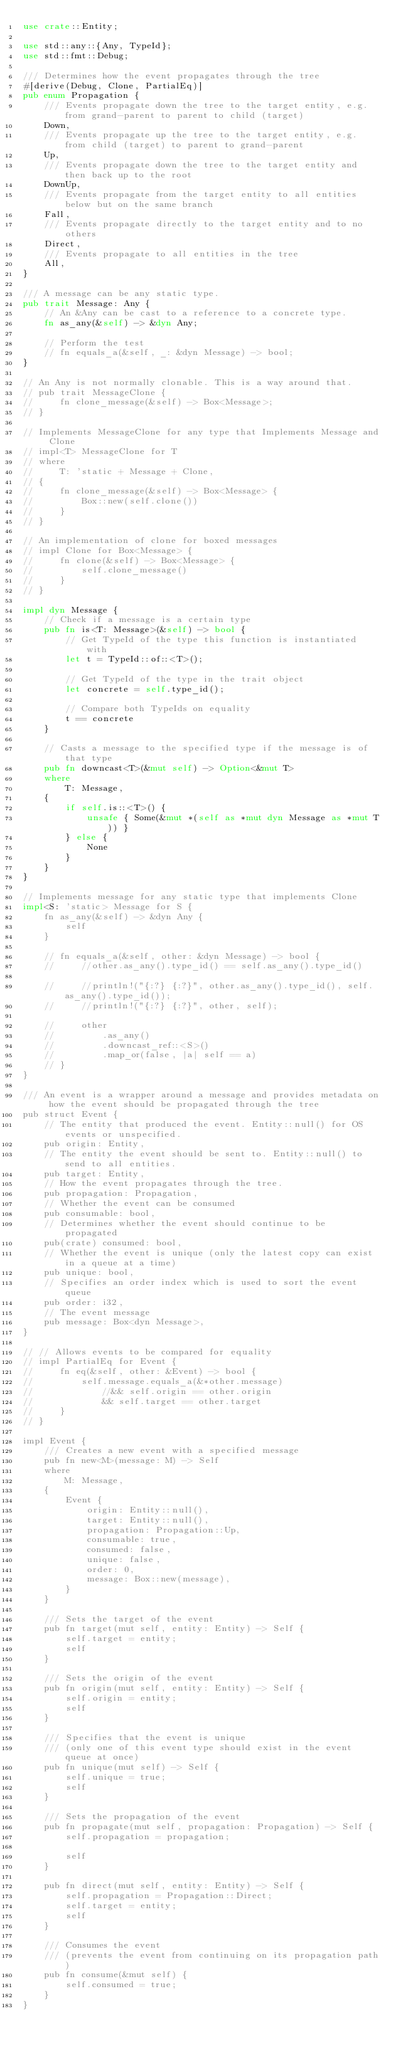Convert code to text. <code><loc_0><loc_0><loc_500><loc_500><_Rust_>use crate::Entity;

use std::any::{Any, TypeId};
use std::fmt::Debug;

/// Determines how the event propagates through the tree
#[derive(Debug, Clone, PartialEq)]
pub enum Propagation {
    /// Events propagate down the tree to the target entity, e.g. from grand-parent to parent to child (target)
    Down,
    /// Events propagate up the tree to the target entity, e.g. from child (target) to parent to grand-parent
    Up,
    /// Events propagate down the tree to the target entity and then back up to the root
    DownUp,
    /// Events propagate from the target entity to all entities below but on the same branch
    Fall,
    /// Events propagate directly to the target entity and to no others
    Direct,
    /// Events propagate to all entities in the tree
    All,
}

/// A message can be any static type.
pub trait Message: Any {
    // An &Any can be cast to a reference to a concrete type.
    fn as_any(&self) -> &dyn Any;

    // Perform the test
    // fn equals_a(&self, _: &dyn Message) -> bool;
}

// An Any is not normally clonable. This is a way around that.
// pub trait MessageClone {
//     fn clone_message(&self) -> Box<Message>;
// }

// Implements MessageClone for any type that Implements Message and Clone
// impl<T> MessageClone for T
// where
//     T: 'static + Message + Clone,
// {
//     fn clone_message(&self) -> Box<Message> {
//         Box::new(self.clone())
//     }
// }

// An implementation of clone for boxed messages
// impl Clone for Box<Message> {
//     fn clone(&self) -> Box<Message> {
//         self.clone_message()
//     }
// }

impl dyn Message {
    // Check if a message is a certain type
    pub fn is<T: Message>(&self) -> bool {
        // Get TypeId of the type this function is instantiated with
        let t = TypeId::of::<T>();

        // Get TypeId of the type in the trait object
        let concrete = self.type_id();

        // Compare both TypeIds on equality
        t == concrete
    }

    // Casts a message to the specified type if the message is of that type
    pub fn downcast<T>(&mut self) -> Option<&mut T>
    where
        T: Message,
    {
        if self.is::<T>() {
            unsafe { Some(&mut *(self as *mut dyn Message as *mut T)) }
        } else {
            None
        }
    }
}

// Implements message for any static type that implements Clone
impl<S: 'static> Message for S {
    fn as_any(&self) -> &dyn Any {
        self
    }

    // fn equals_a(&self, other: &dyn Message) -> bool {
    //     //other.as_any().type_id() == self.as_any().type_id()

    //     //println!("{:?} {:?}", other.as_any().type_id(), self.as_any().type_id());
    //     //println!("{:?} {:?}", other, self);

    //     other
    //         .as_any()
    //         .downcast_ref::<S>()
    //         .map_or(false, |a| self == a)
    // }
}

/// An event is a wrapper around a message and provides metadata on how the event should be propagated through the tree
pub struct Event {
    // The entity that produced the event. Entity::null() for OS events or unspecified.
    pub origin: Entity,
    // The entity the event should be sent to. Entity::null() to send to all entities.
    pub target: Entity,
    // How the event propagates through the tree.
    pub propagation: Propagation,
    // Whether the event can be consumed
    pub consumable: bool,
    // Determines whether the event should continue to be propagated
    pub(crate) consumed: bool,
    // Whether the event is unique (only the latest copy can exist in a queue at a time)
    pub unique: bool,
    // Specifies an order index which is used to sort the event queue
    pub order: i32,
    // The event message
    pub message: Box<dyn Message>,
}

// // Allows events to be compared for equality
// impl PartialEq for Event {
//     fn eq(&self, other: &Event) -> bool {
//         self.message.equals_a(&*other.message)
//             //&& self.origin == other.origin
//             && self.target == other.target
//     }
// }

impl Event {
    /// Creates a new event with a specified message
    pub fn new<M>(message: M) -> Self
    where
        M: Message,
    {
        Event {
            origin: Entity::null(),
            target: Entity::null(),
            propagation: Propagation::Up,
            consumable: true,
            consumed: false,
            unique: false,
            order: 0,
            message: Box::new(message),
        }
    }

    /// Sets the target of the event
    pub fn target(mut self, entity: Entity) -> Self {
        self.target = entity;
        self
    }

    /// Sets the origin of the event
    pub fn origin(mut self, entity: Entity) -> Self {
        self.origin = entity;
        self
    }

    /// Specifies that the event is unique
    /// (only one of this event type should exist in the event queue at once)
    pub fn unique(mut self) -> Self {
        self.unique = true;
        self
    }

    /// Sets the propagation of the event
    pub fn propagate(mut self, propagation: Propagation) -> Self {
        self.propagation = propagation;

        self
    }

    pub fn direct(mut self, entity: Entity) -> Self {
        self.propagation = Propagation::Direct;
        self.target = entity;
        self
    }

    /// Consumes the event
    /// (prevents the event from continuing on its propagation path)
    pub fn consume(&mut self) {
        self.consumed = true;
    }
}
</code> 